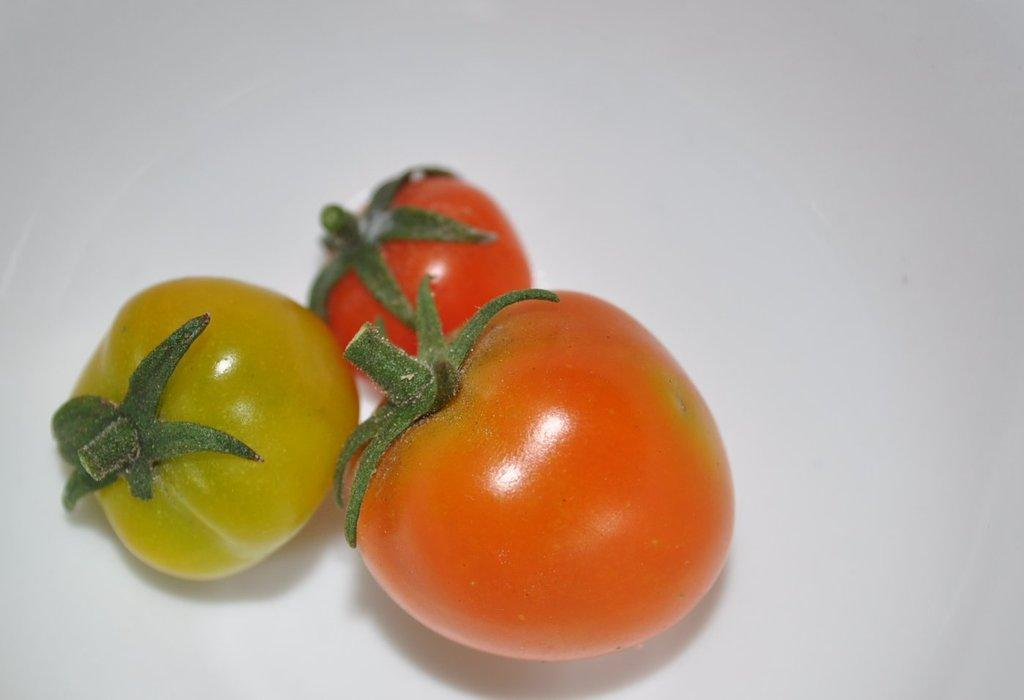What type of fruit is present in the image? There are tomatoes in the image. Where are the tomatoes located? The tomatoes are on a white platform. What color is the dress worn by the tomatoes in the image? There is no dress present in the image, as tomatoes are not capable of wearing clothing. 